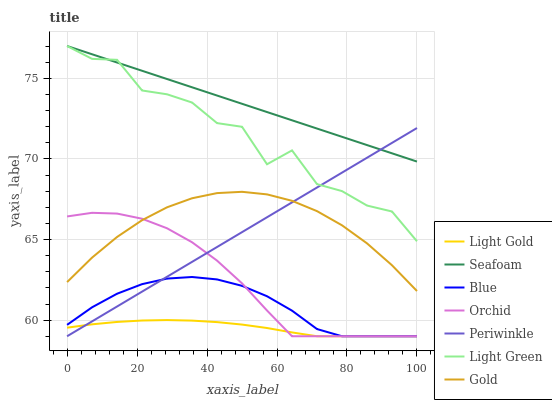Does Light Gold have the minimum area under the curve?
Answer yes or no. Yes. Does Seafoam have the maximum area under the curve?
Answer yes or no. Yes. Does Gold have the minimum area under the curve?
Answer yes or no. No. Does Gold have the maximum area under the curve?
Answer yes or no. No. Is Periwinkle the smoothest?
Answer yes or no. Yes. Is Light Green the roughest?
Answer yes or no. Yes. Is Gold the smoothest?
Answer yes or no. No. Is Gold the roughest?
Answer yes or no. No. Does Blue have the lowest value?
Answer yes or no. Yes. Does Gold have the lowest value?
Answer yes or no. No. Does Light Green have the highest value?
Answer yes or no. Yes. Does Gold have the highest value?
Answer yes or no. No. Is Light Gold less than Gold?
Answer yes or no. Yes. Is Seafoam greater than Gold?
Answer yes or no. Yes. Does Periwinkle intersect Light Gold?
Answer yes or no. Yes. Is Periwinkle less than Light Gold?
Answer yes or no. No. Is Periwinkle greater than Light Gold?
Answer yes or no. No. Does Light Gold intersect Gold?
Answer yes or no. No. 